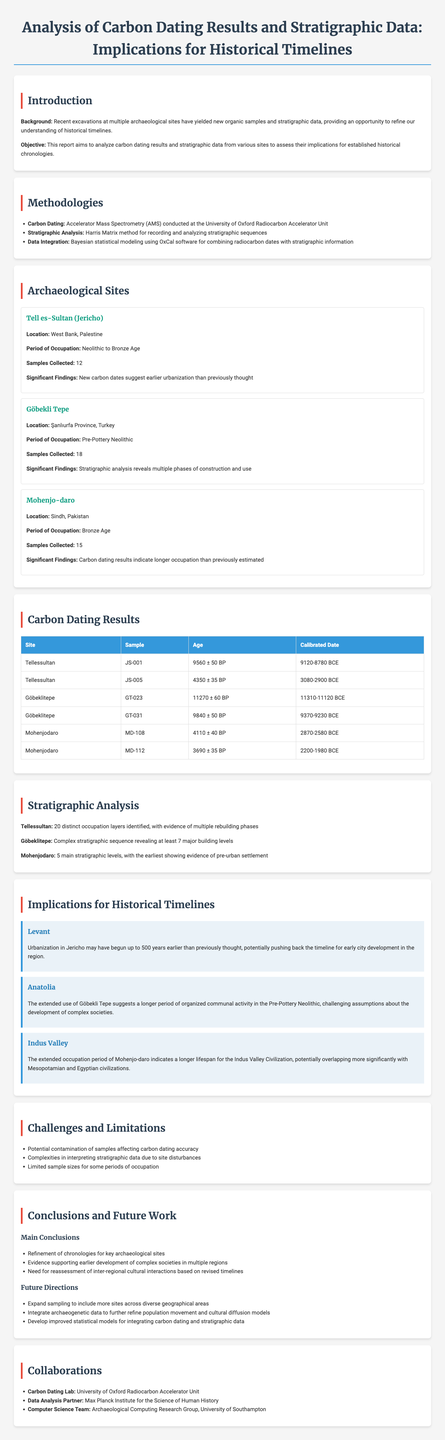what is the title of the report? The title of the report is specified in the metadata section of the document.
Answer: Analysis of Carbon Dating Results and Stratigraphic Data: Implications for Historical Timelines how many samples were collected from Göbekli Tepe? The document lists the number of samples collected from each archaeological site in the respective sections.
Answer: 18 what age is the carbon dating result for sample JS-001 from Tell es-Sultan? The age of the carbon dating result is provided in the carbon dating results section associated with the corresponding sample.
Answer: 9560 ± 50 BP which method was used for stratigraphic analysis? The methodologies section contains detailed information about the methods used for different analyses in the report.
Answer: Harris Matrix what implication does the report suggest for the Levant region? The implications for historical timelines section discusses the impact of findings on different regions.
Answer: Urbanization in Jericho may have begun up to 500 years earlier than previously thought how many distinct occupation layers were identified at Tell es-Sultan? The number of distinct occupation layers is detailed in the stratigraphic analysis section for each site.
Answer: 20 which laboratory conducted the carbon dating? The collaborations section specifies the institutions involved in the research.
Answer: University of Oxford Radiocarbon Accelerator Unit what is one of the future directions suggested in the report? The conclusions and future work section outlines potential actions for subsequent research.
Answer: Expand sampling to include more sites across diverse geographical areas what was found regarding the occupation period of Mohenjo-daro? Significant findings regarding occupation periods are highlighted in the findings of each archaeological site.
Answer: Longer occupation than previously estimated 